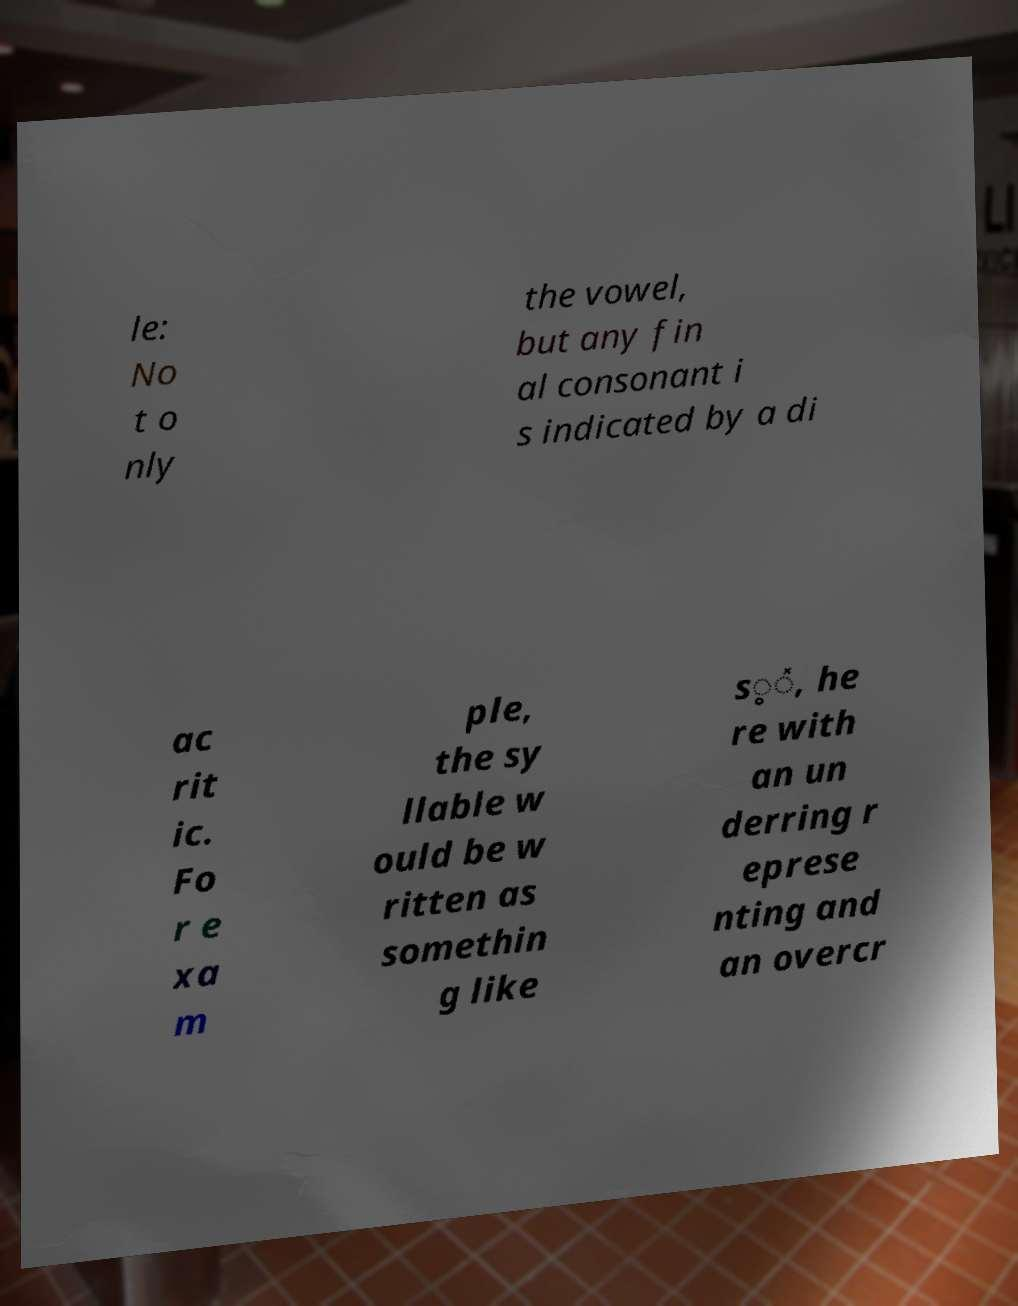There's text embedded in this image that I need extracted. Can you transcribe it verbatim? le: No t o nly the vowel, but any fin al consonant i s indicated by a di ac rit ic. Fo r e xa m ple, the sy llable w ould be w ritten as somethin g like s̥̽, he re with an un derring r eprese nting and an overcr 